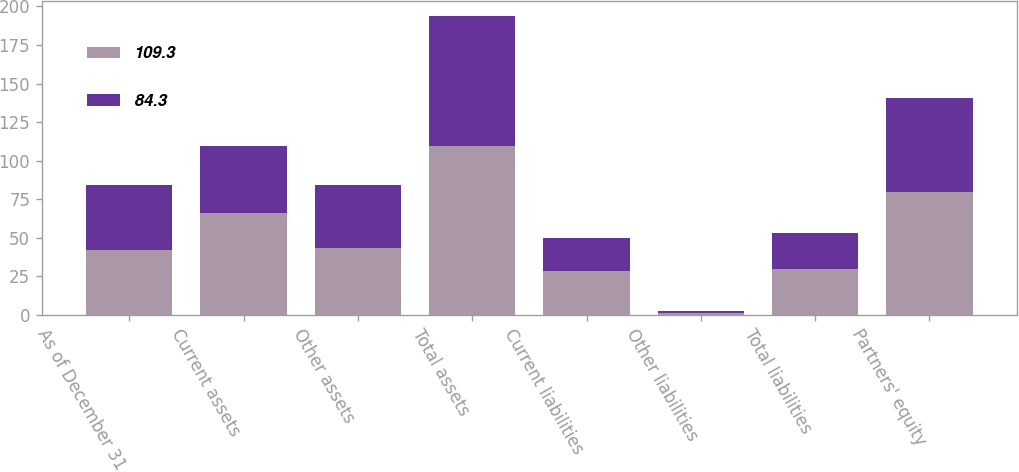Convert chart to OTSL. <chart><loc_0><loc_0><loc_500><loc_500><stacked_bar_chart><ecel><fcel>As of December 31<fcel>Current assets<fcel>Other assets<fcel>Total assets<fcel>Current liabilities<fcel>Other liabilities<fcel>Total liabilities<fcel>Partners' equity<nl><fcel>109.3<fcel>42.1<fcel>66<fcel>43.3<fcel>109.3<fcel>28.2<fcel>1.4<fcel>29.6<fcel>79.7<nl><fcel>84.3<fcel>42.1<fcel>43.4<fcel>40.9<fcel>84.3<fcel>21.9<fcel>1.3<fcel>23.2<fcel>61.1<nl></chart> 